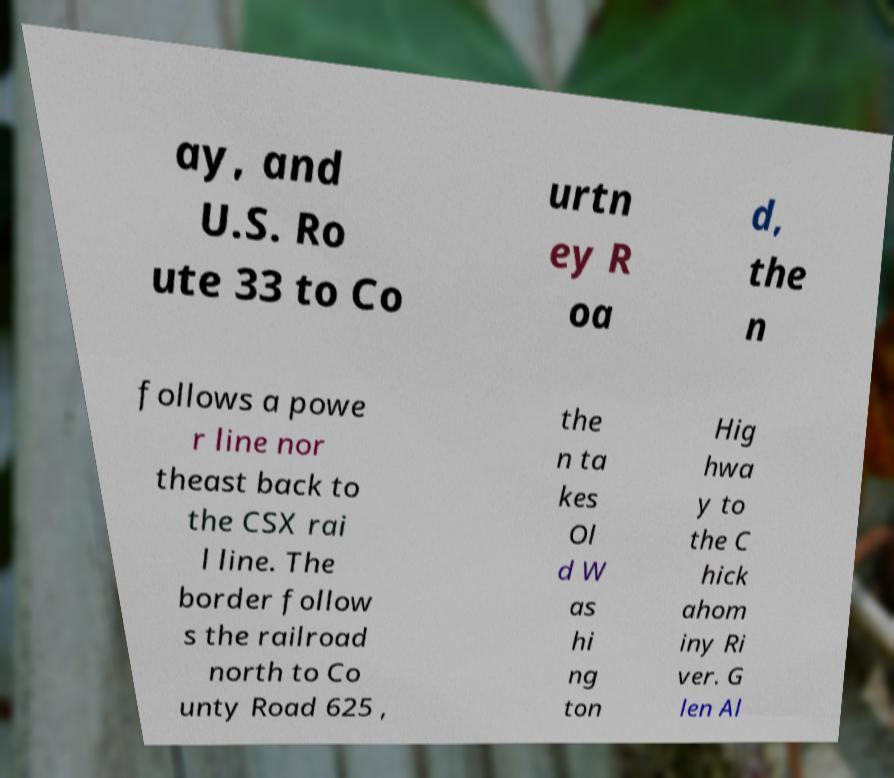Please identify and transcribe the text found in this image. ay, and U.S. Ro ute 33 to Co urtn ey R oa d, the n follows a powe r line nor theast back to the CSX rai l line. The border follow s the railroad north to Co unty Road 625 , the n ta kes Ol d W as hi ng ton Hig hwa y to the C hick ahom iny Ri ver. G len Al 